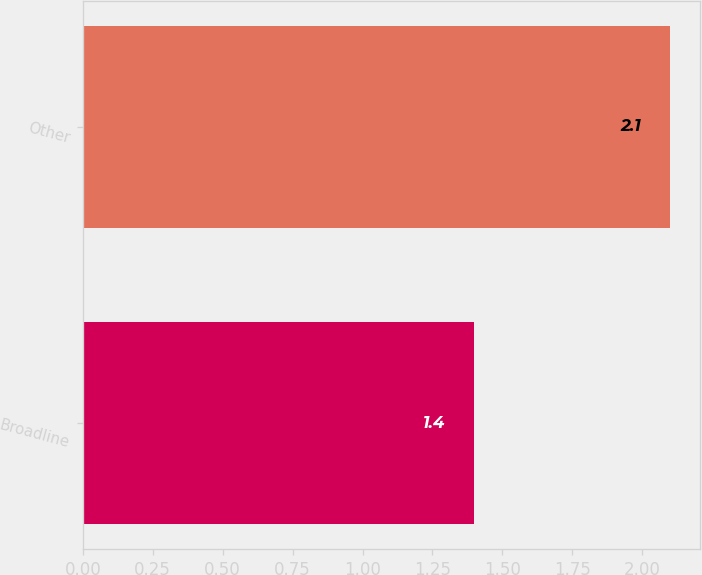Convert chart. <chart><loc_0><loc_0><loc_500><loc_500><bar_chart><fcel>Broadline<fcel>Other<nl><fcel>1.4<fcel>2.1<nl></chart> 